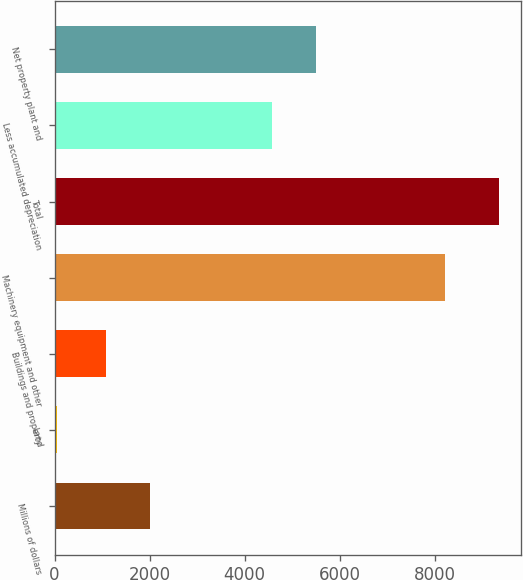Convert chart to OTSL. <chart><loc_0><loc_0><loc_500><loc_500><bar_chart><fcel>Millions of dollars<fcel>Land<fcel>Buildings and property<fcel>Machinery equipment and other<fcel>Total<fcel>Less accumulated depreciation<fcel>Net property plant and<nl><fcel>2011<fcel>58<fcel>1082<fcel>8208<fcel>9348<fcel>4566<fcel>5495<nl></chart> 